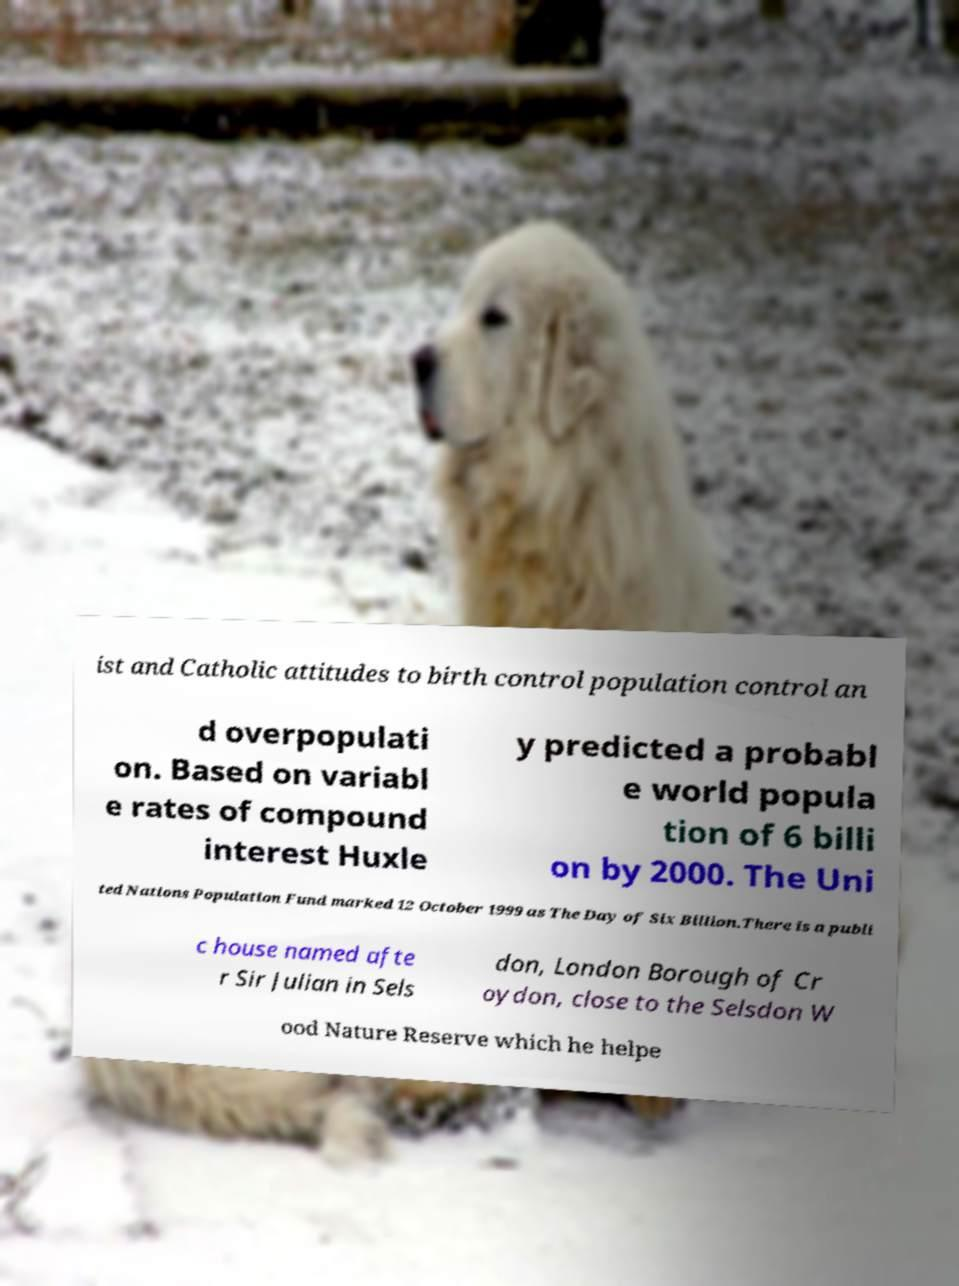For documentation purposes, I need the text within this image transcribed. Could you provide that? ist and Catholic attitudes to birth control population control an d overpopulati on. Based on variabl e rates of compound interest Huxle y predicted a probabl e world popula tion of 6 billi on by 2000. The Uni ted Nations Population Fund marked 12 October 1999 as The Day of Six Billion.There is a publi c house named afte r Sir Julian in Sels don, London Borough of Cr oydon, close to the Selsdon W ood Nature Reserve which he helpe 